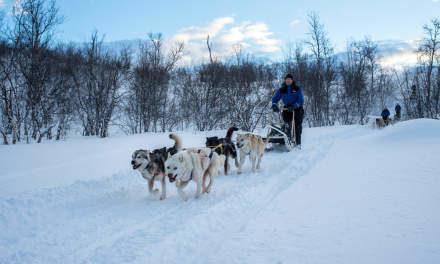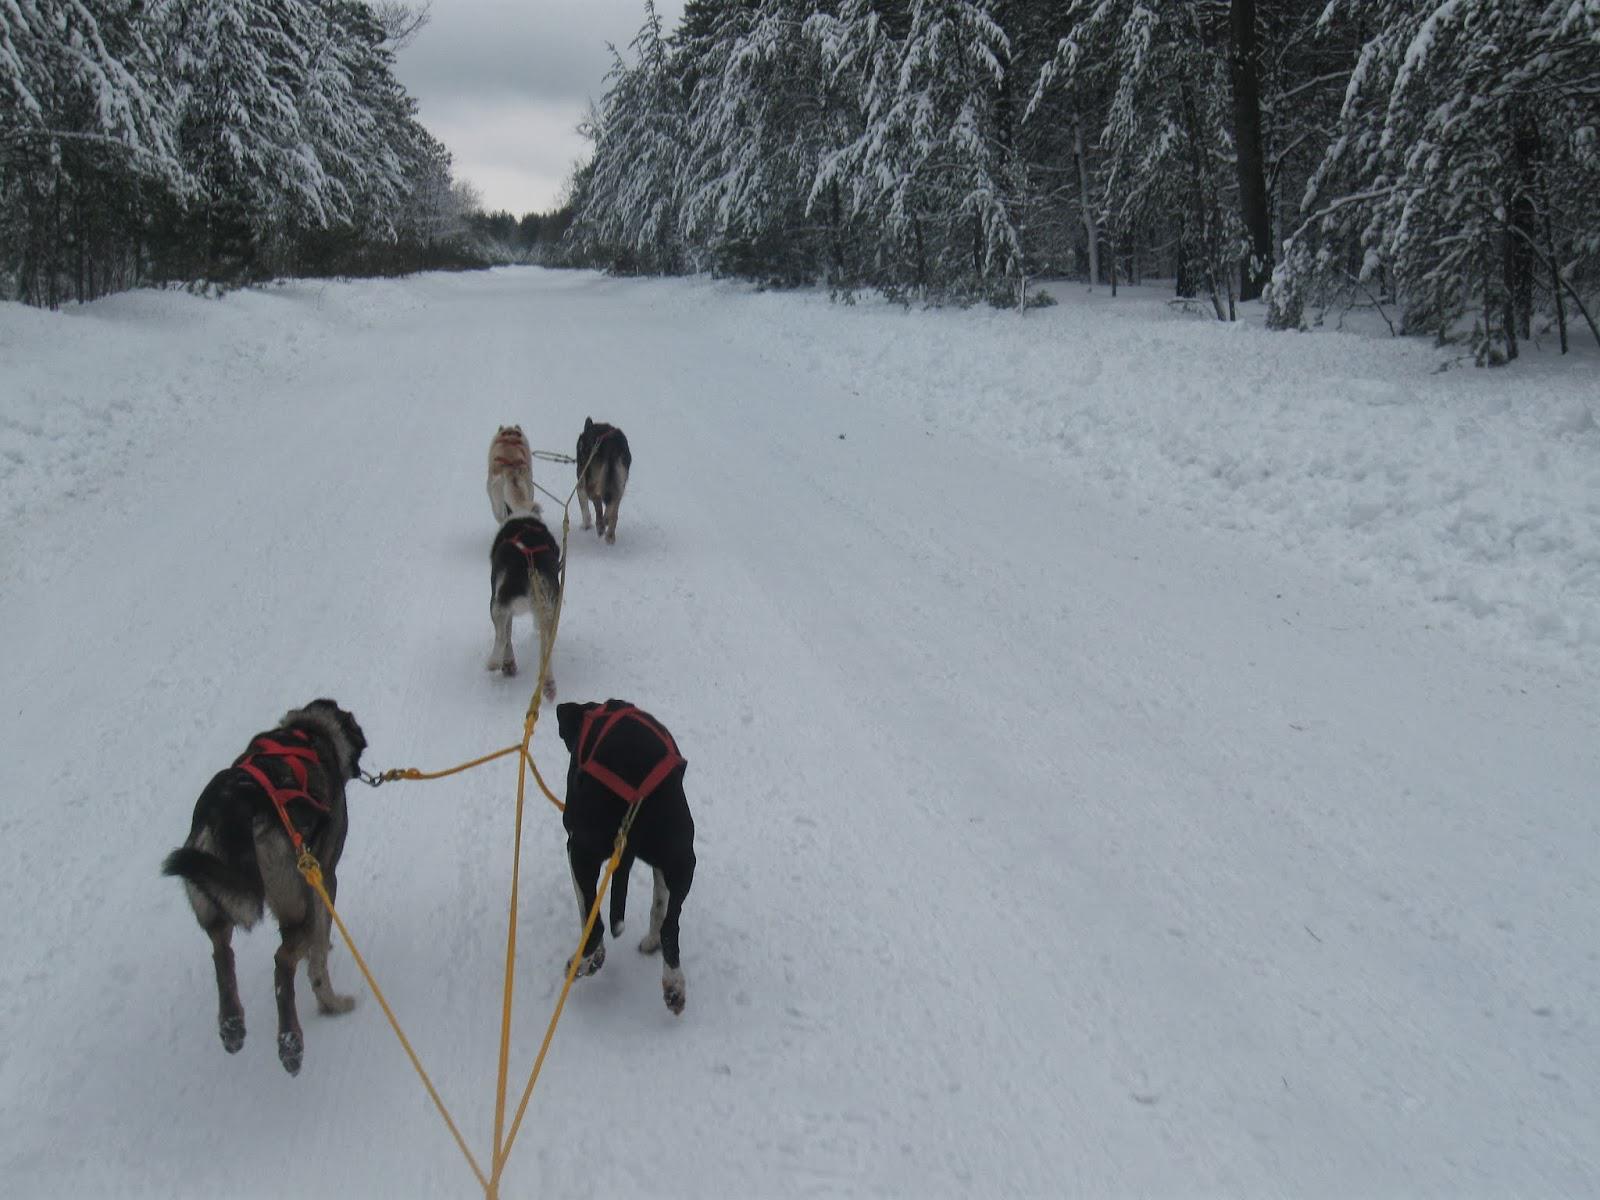The first image is the image on the left, the second image is the image on the right. Evaluate the accuracy of this statement regarding the images: "The dog team in the right image is moving away from the camera, and the dog team on the left is also moving, but not away from the camera.". Is it true? Answer yes or no. Yes. 